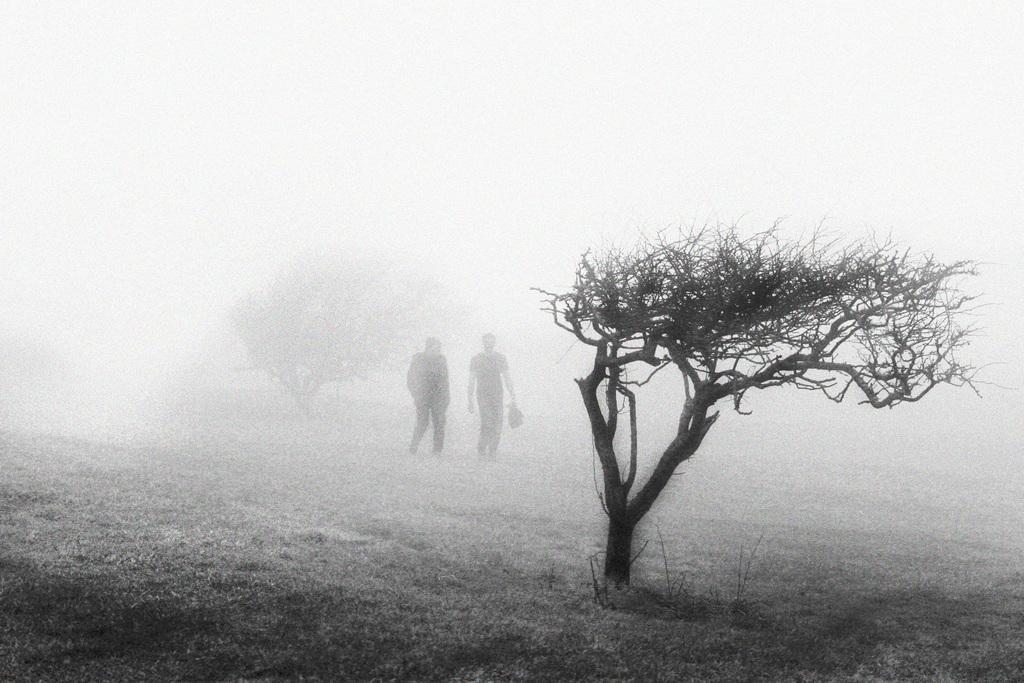Please provide a concise description of this image. In this picture we can see people's, trees on the ground and in the background we can see it is white color. 